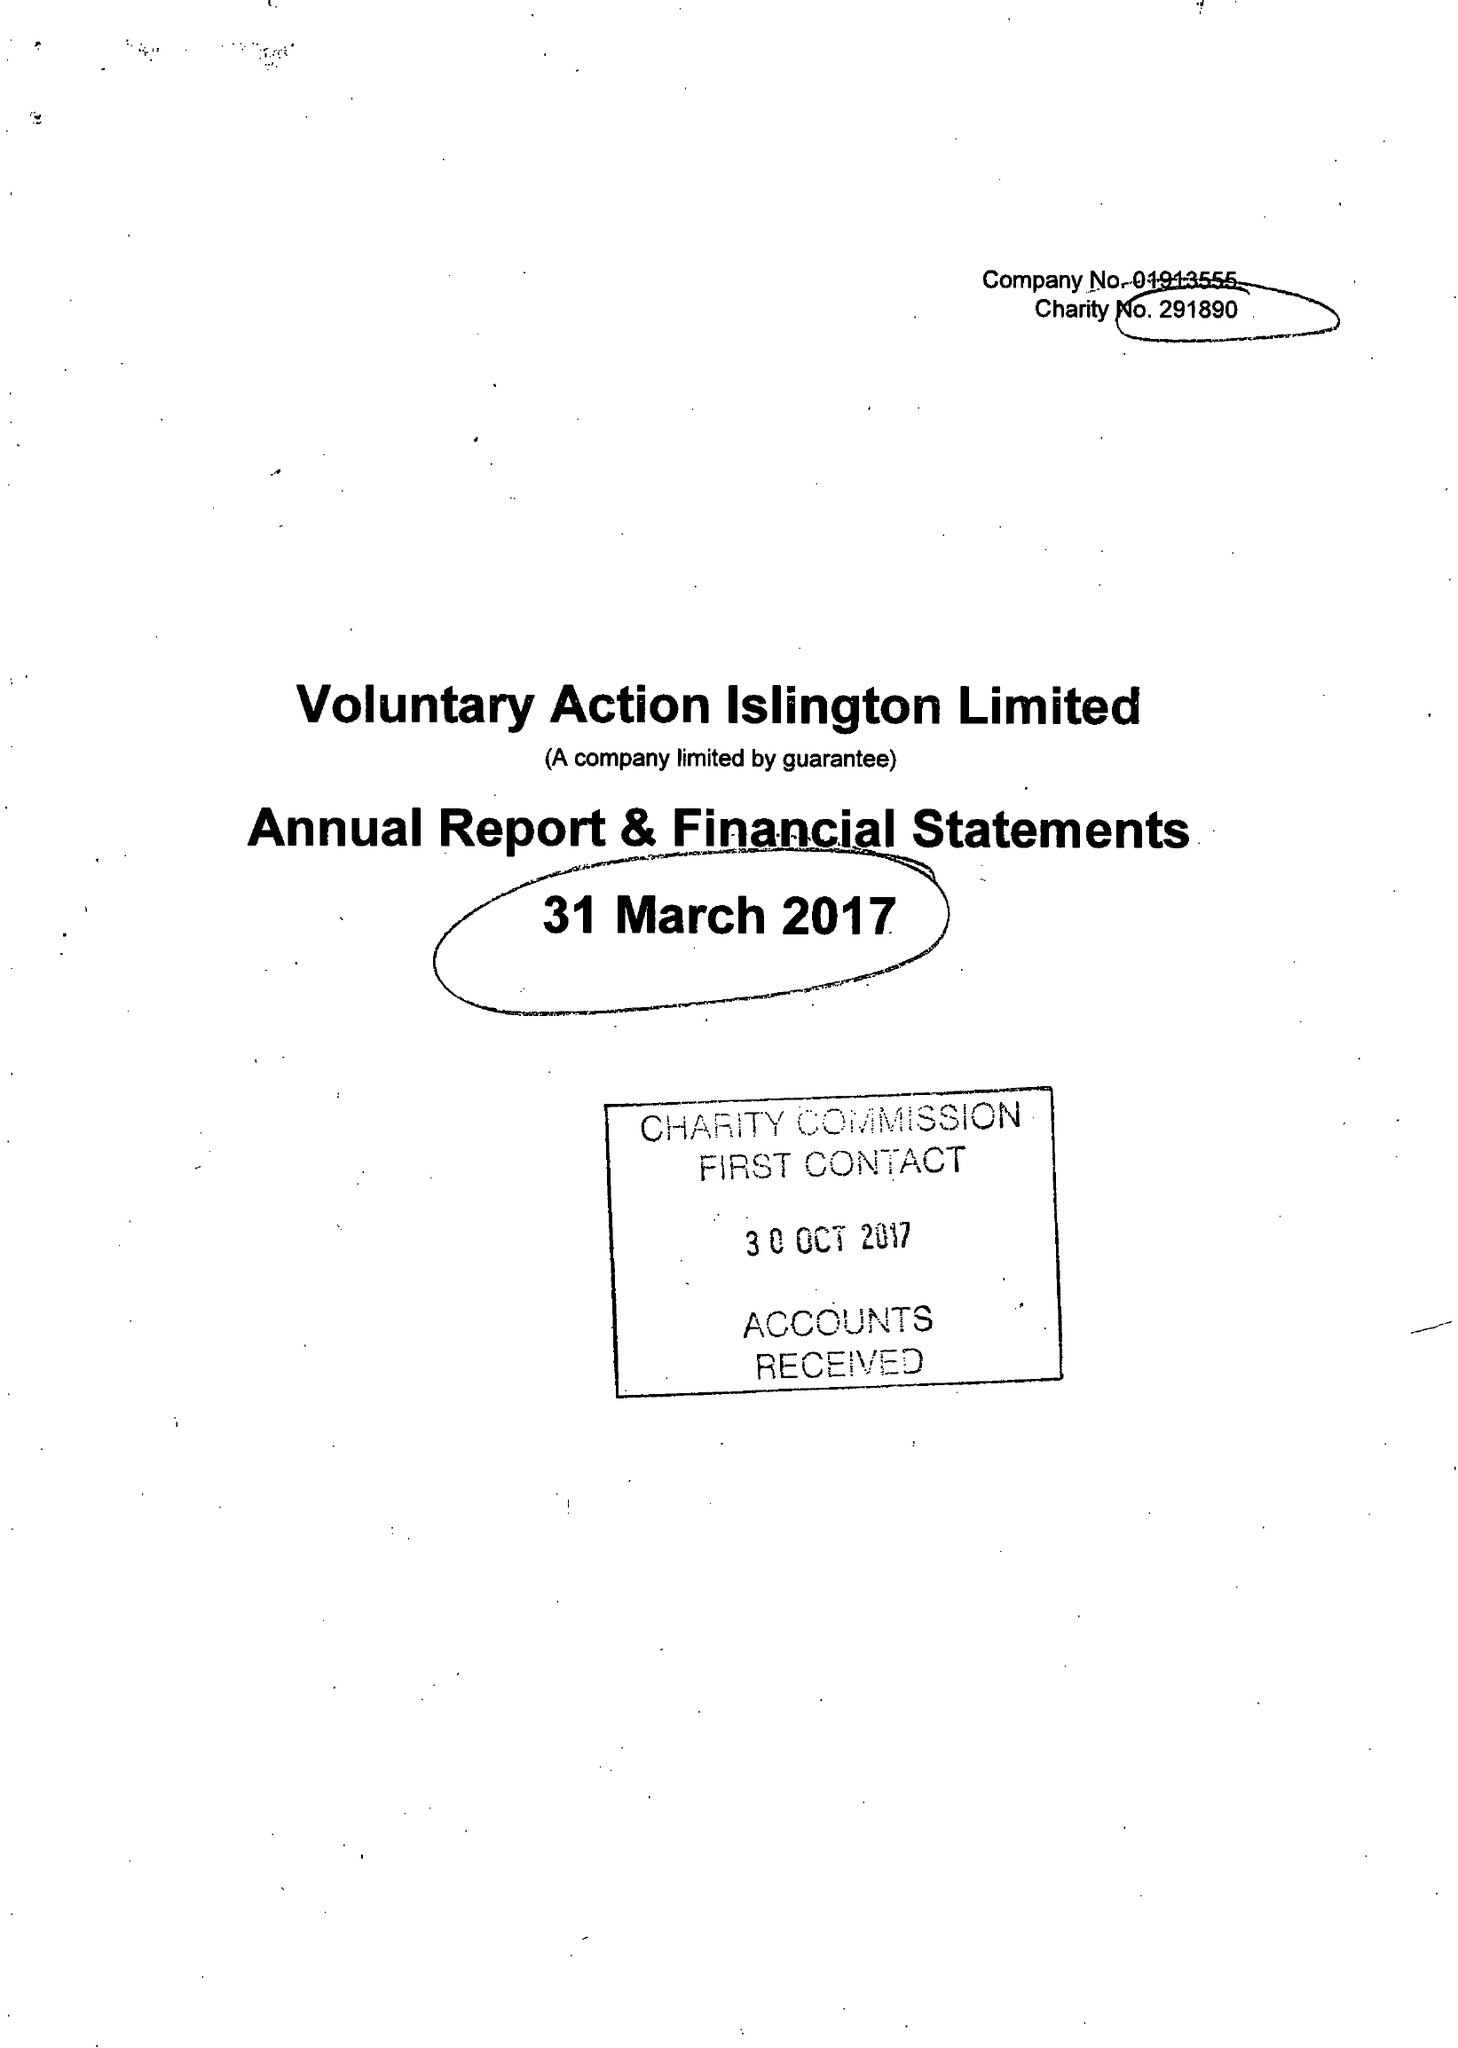What is the value for the address__street_line?
Answer the question using a single word or phrase. 200A PENTONVILLE ROAD 